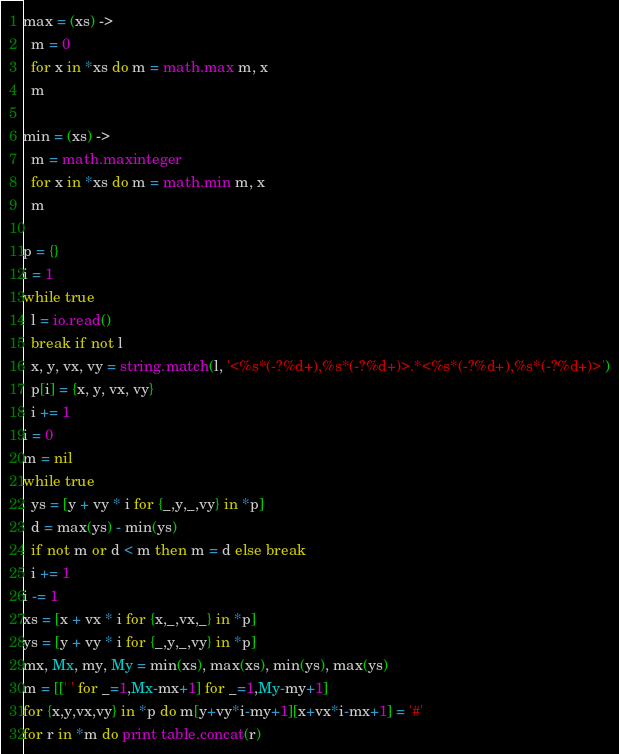<code> <loc_0><loc_0><loc_500><loc_500><_MoonScript_>max = (xs) ->
  m = 0
  for x in *xs do m = math.max m, x
  m

min = (xs) ->
  m = math.maxinteger
  for x in *xs do m = math.min m, x
  m

p = {}
i = 1
while true
  l = io.read()
  break if not l
  x, y, vx, vy = string.match(l, '<%s*(-?%d+),%s*(-?%d+)>.*<%s*(-?%d+),%s*(-?%d+)>')
  p[i] = {x, y, vx, vy}
  i += 1
i = 0
m = nil
while true
  ys = [y + vy * i for {_,y,_,vy} in *p]
  d = max(ys) - min(ys)
  if not m or d < m then m = d else break
  i += 1
i -= 1
xs = [x + vx * i for {x,_,vx,_} in *p]
ys = [y + vy * i for {_,y,_,vy} in *p]
mx, Mx, my, My = min(xs), max(xs), min(ys), max(ys)
m = [[' ' for _=1,Mx-mx+1] for _=1,My-my+1]
for {x,y,vx,vy} in *p do m[y+vy*i-my+1][x+vx*i-mx+1] = '#'
for r in *m do print table.concat(r)
</code> 